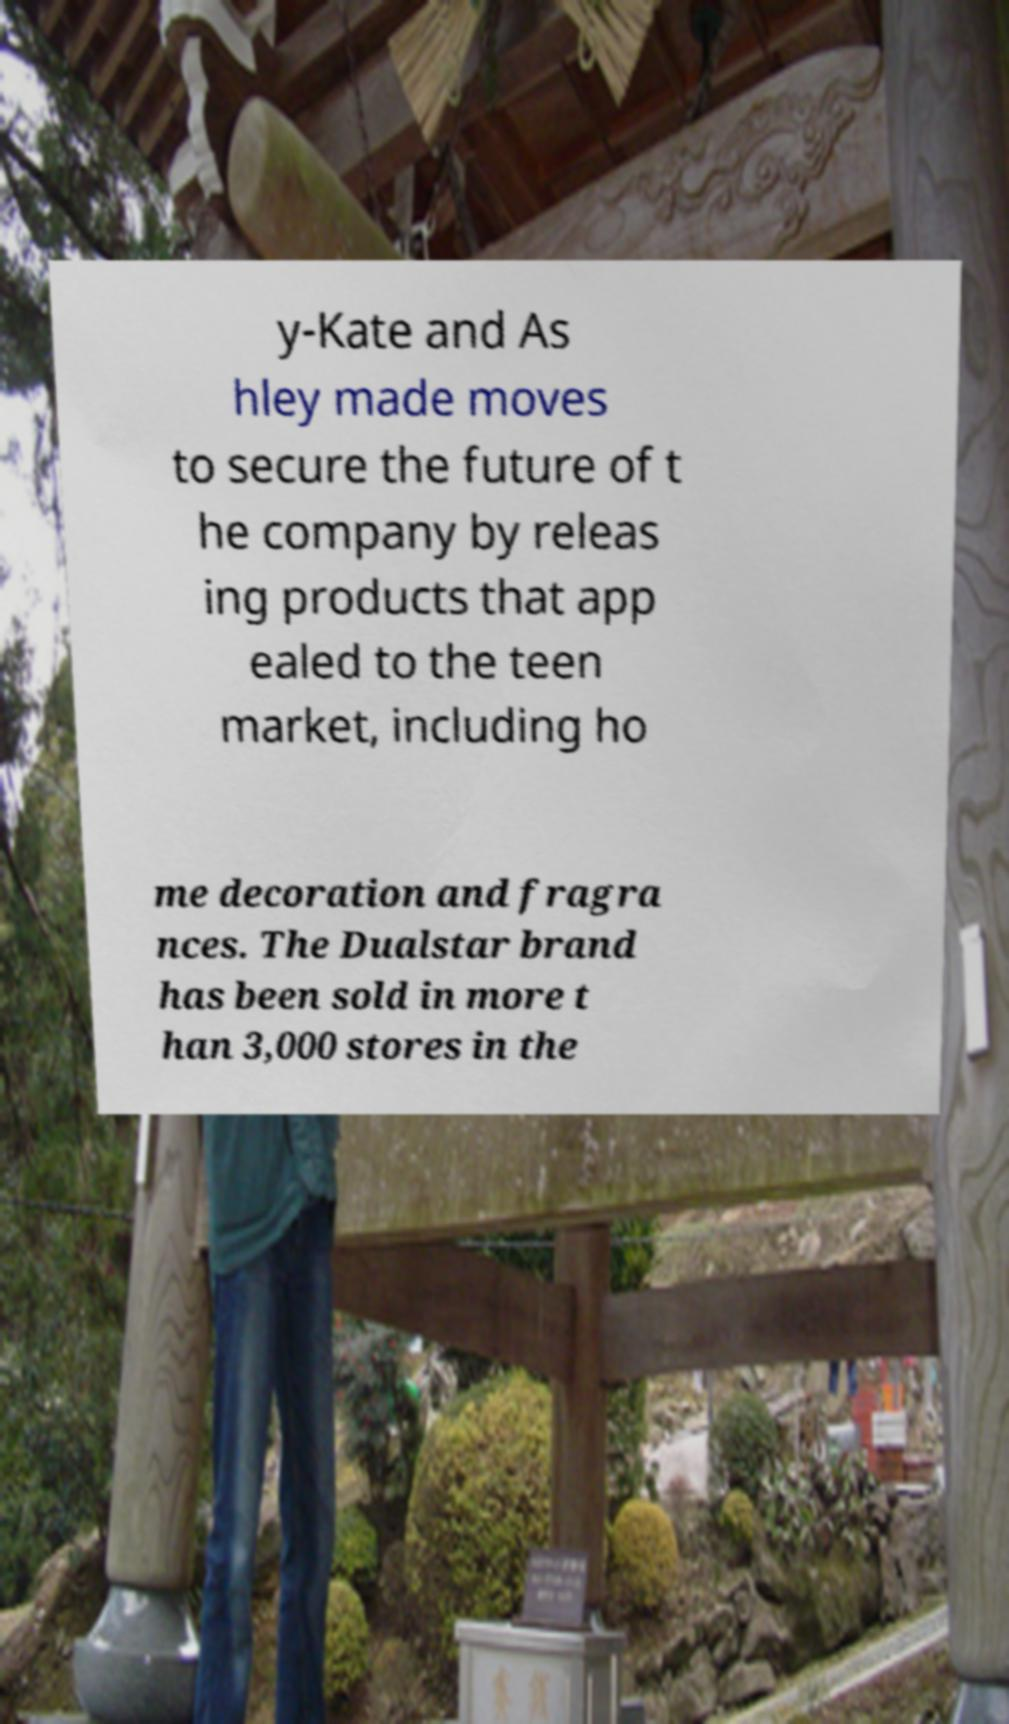What messages or text are displayed in this image? I need them in a readable, typed format. y-Kate and As hley made moves to secure the future of t he company by releas ing products that app ealed to the teen market, including ho me decoration and fragra nces. The Dualstar brand has been sold in more t han 3,000 stores in the 